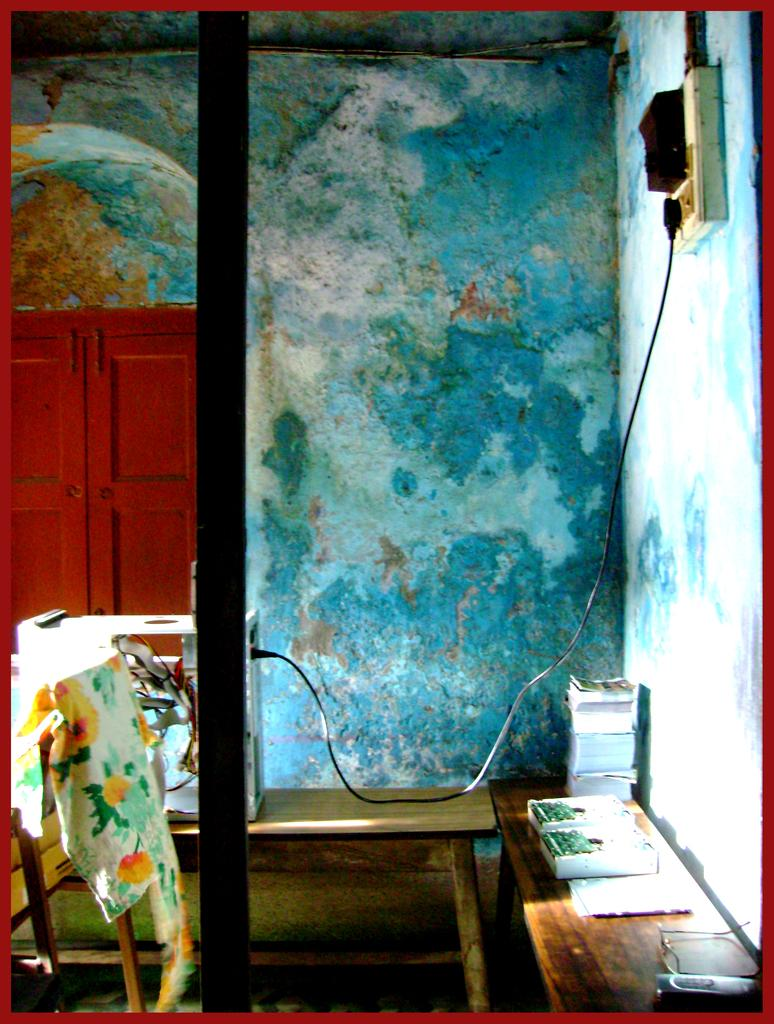What type of structure can be seen in the image? There is a wall in the image. What device is present on the wall? There is a switch board on the wall. What can be seen connected to the switch board? Cables are visible in the image. What type of accessory is present in the image? There are spectacles in the image. What type of item is present in the image that is typically used for learning? There are books in the image. What type of furniture is present in the image? There are other objects on a wooden table in the image. What type of skate is being used on the wooden table in the image? There is no skate present on the wooden table in the image. What type of air is visible in the image? The image does not depict any specific type of air; it is a general concept. 